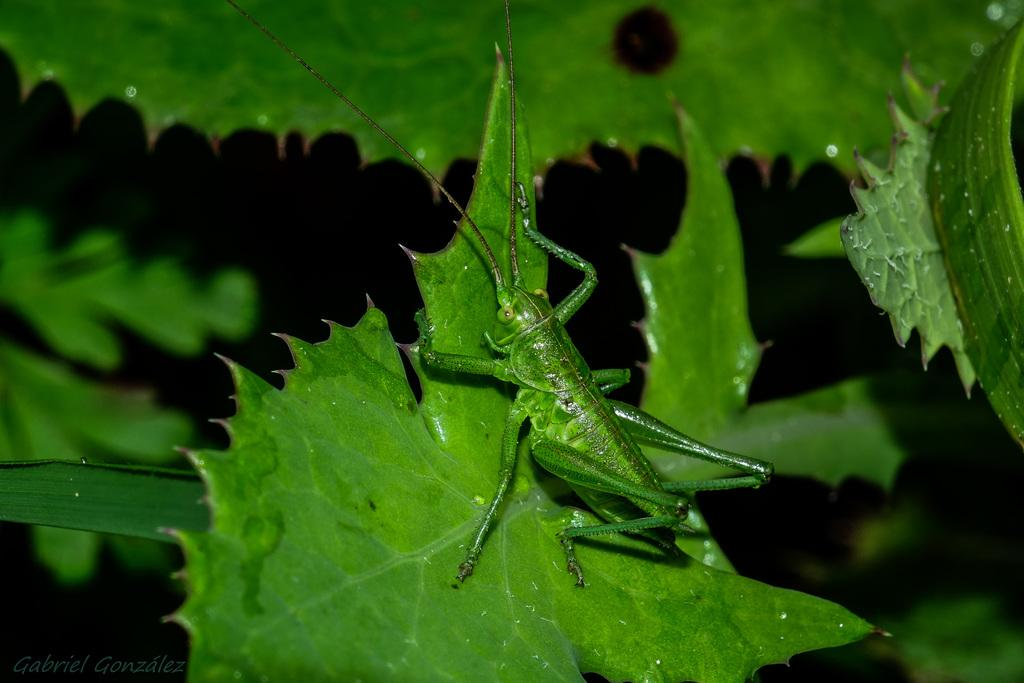What is present on the green leaf in the picture? There is an insect on the green leaf in the picture. Can you describe the insect's location on the leaf? The insect is on the green leaf in the picture. What type of nose does the monkey have in the image? There is no monkey present in the image, so it is not possible to determine the type of nose it might have. 